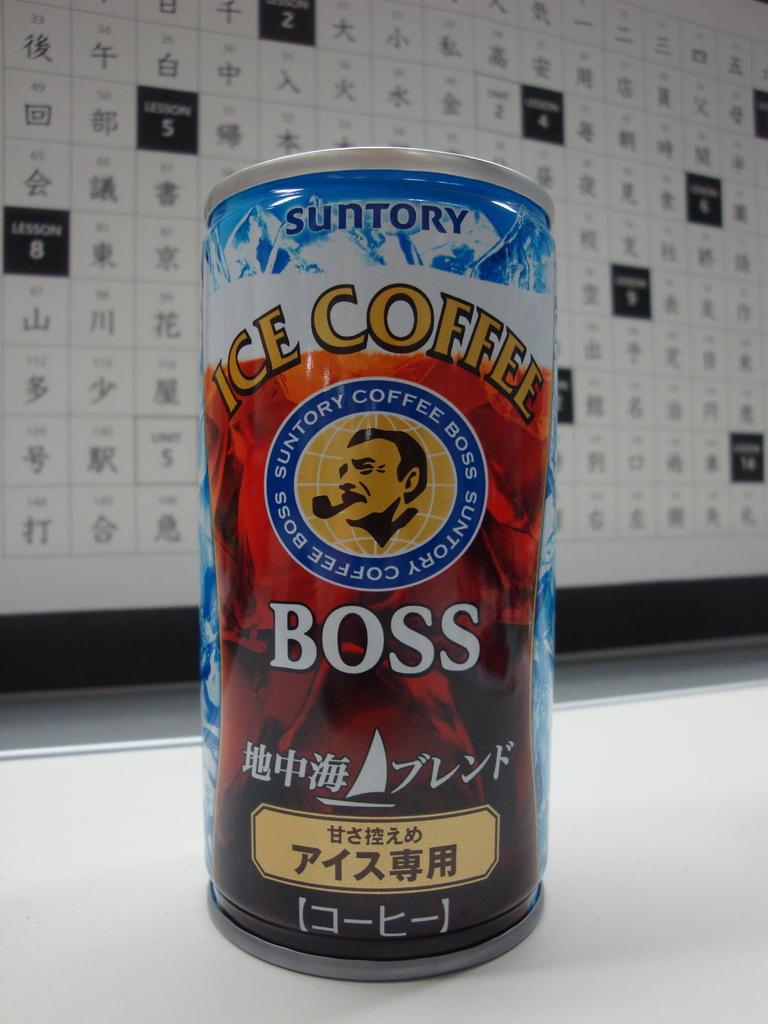Is this ice coffee?
Make the answer very short. Yes. Who is the maker of this ice coffee?
Keep it short and to the point. Suntory. 